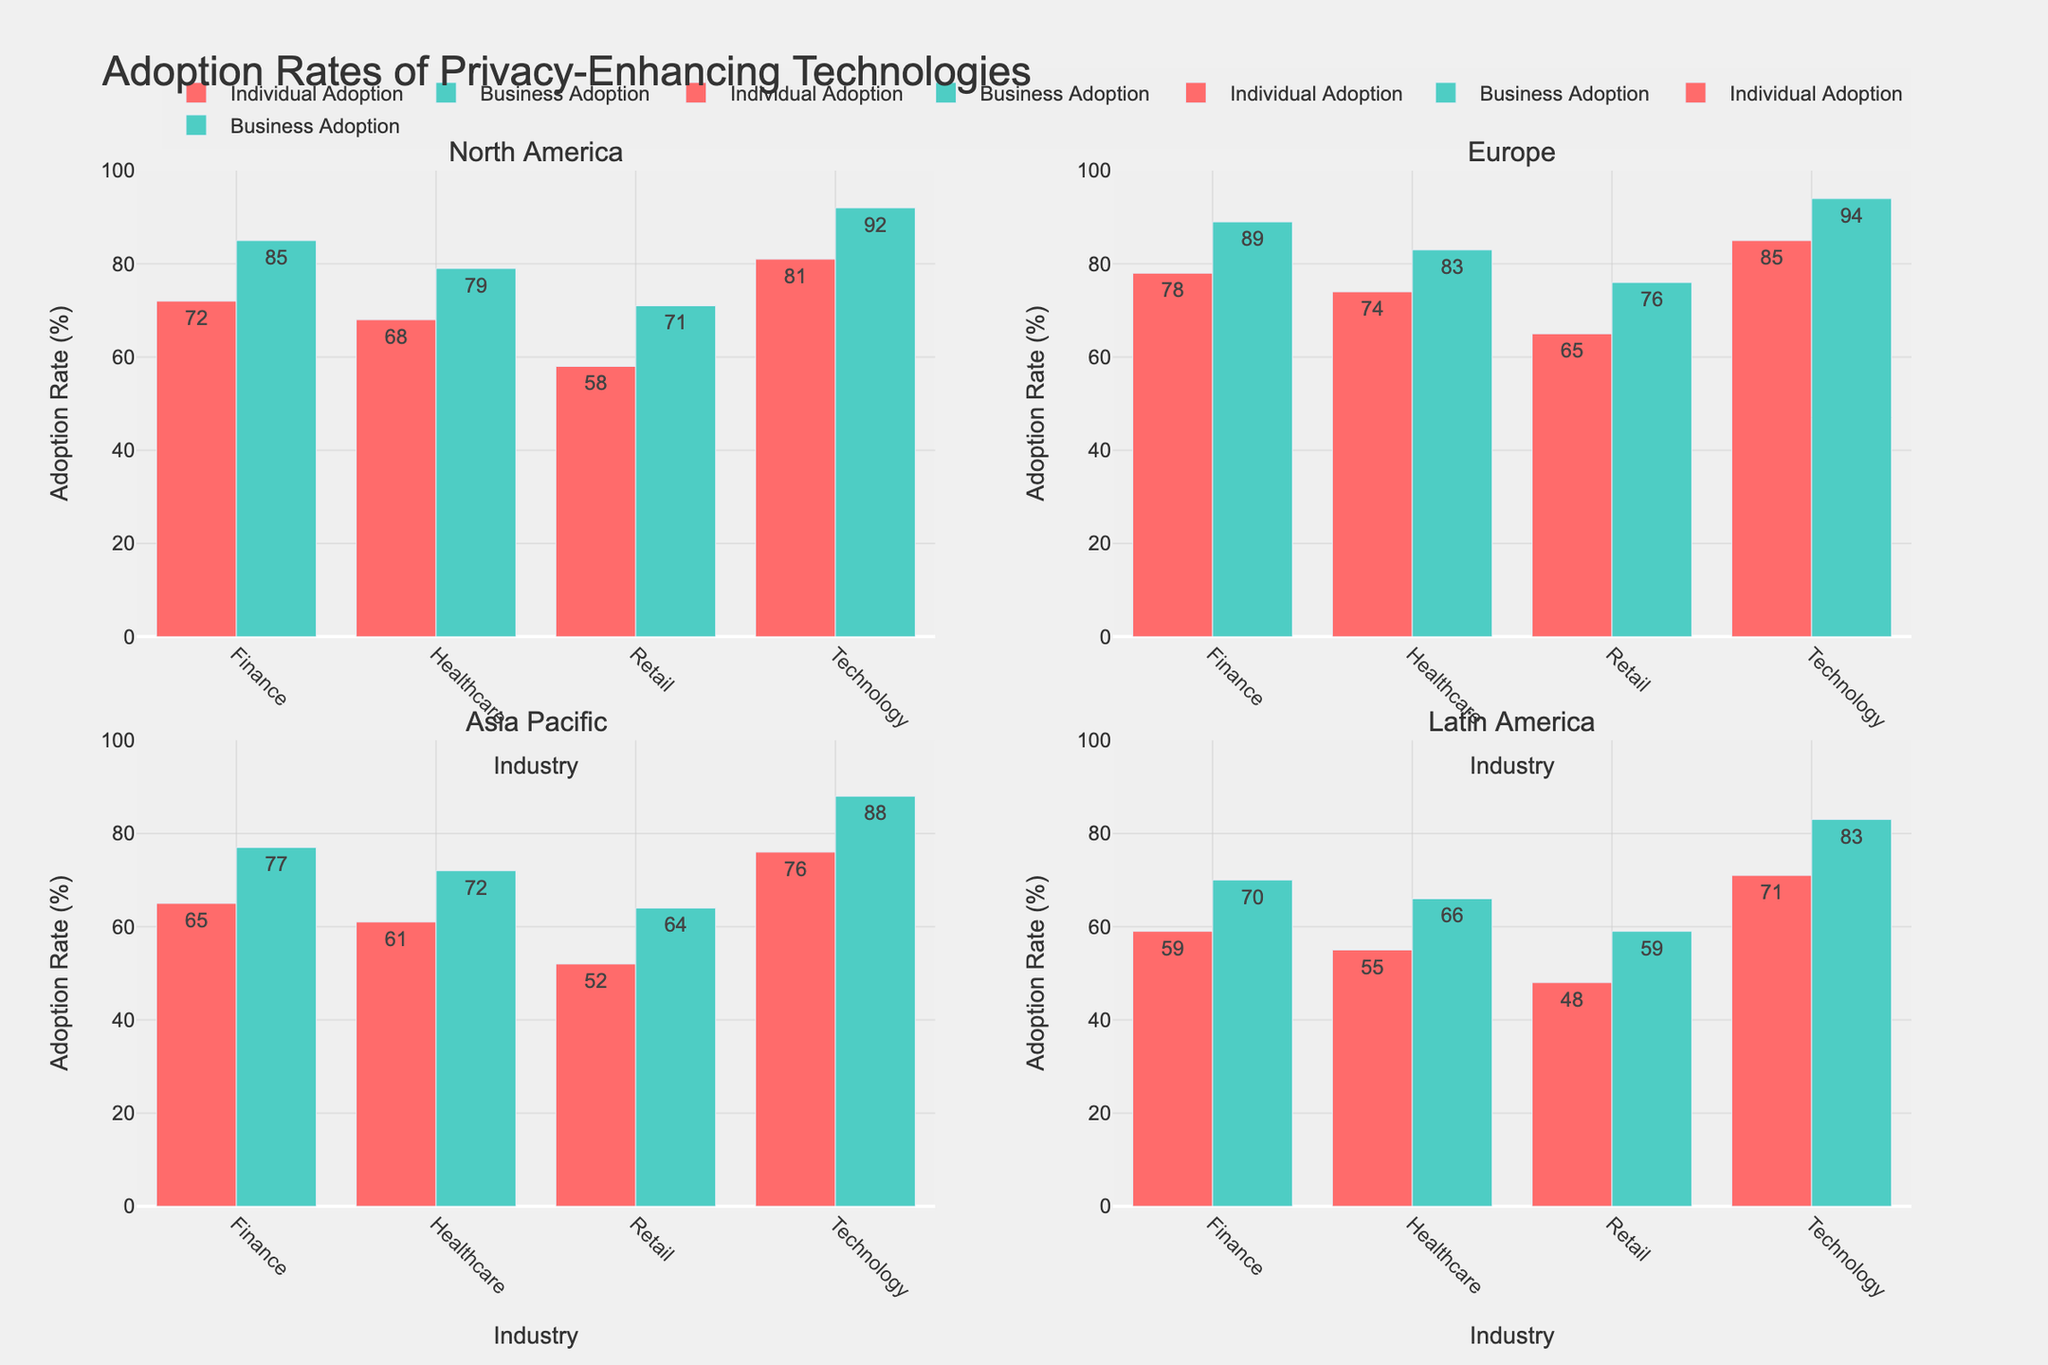Which region has the highest individual adoption rate in the technology industry? In the subplot for each region, look at the bar heights for the technology industry specifically. The highest bar is in the subplot for Europe, indicating the highest individual adoption rate.
Answer: Europe Compare the business adoption rates of privacy-enhancing technologies between the finance industry in North America and Europe. Check the heights of the business adoption rate bars for the finance industry in the North America and Europe subplots. North America has 85%, and Europe has 89%.
Answer: Europe What is the adoption rate difference between individual and business in the healthcare sector in Latin America? Identify the heights of the bars for individual and business adoption in the healthcare sector in Latin America. The rates are 55% and 66%, respectively. The difference is 66% - 55% = 11%.
Answer: 11% Which industry has the lowest individual adoption rate across all regions? Among all subplots, locate the shortest bar indicating individual adoption. The retail industry in Latin America has the lowest rate at 48%.
Answer: Retail in Latin America What is the average business adoption rate in the retail industry across all regions? Locate the business adoption bars for the retail industry across all regions and calculate the average: (71 + 76 + 64 + 59) / 4 = 67.5%.
Answer: 67.5% How does the North American individual adoption rate in the healthcare industry compare to the European rate? Is it higher or lower? Locate the individual adoption bars for the healthcare industry in North America (68%) and Europe (74%). The rate in North America is lower.
Answer: Lower What is the range of business adoption rates in the technology sector across all regions? Find the highest and lowest business adoption bars in the technology sector: 94% in Europe and 83% in Latin America. The range is 94% - 83% = 11%.
Answer: 11% Calculate the average individual adoption rate in the finance industry across all regions. Locate the individual adoption bars for the finance industry and calculate: (72 + 78 + 65 + 59) / 4 = 68.5%.
Answer: 68.5% Which region shows the largest gap between individual and business adoption rates in the technology sector? Compare the gaps between individual and business adoption rates in the technology sector for all regions. The largest gap is in North America: 92% - 81% = 11%.
Answer: North America What is the sum of individual adoption rates in the healthcare industry across North America and Asia Pacific? Add the individual adoption rates in the healthcare industry for North America (68%) and Asia Pacific (61%): 68 + 61 = 129%.
Answer: 129% 